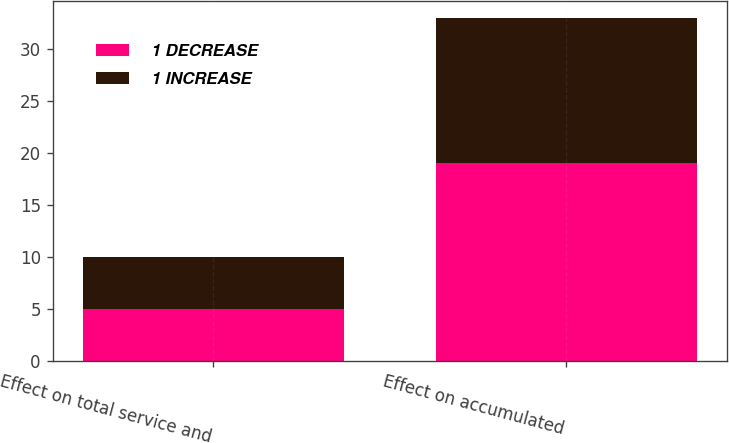<chart> <loc_0><loc_0><loc_500><loc_500><stacked_bar_chart><ecel><fcel>Effect on total service and<fcel>Effect on accumulated<nl><fcel>1 DECREASE<fcel>5<fcel>19<nl><fcel>1 INCREASE<fcel>5<fcel>14<nl></chart> 